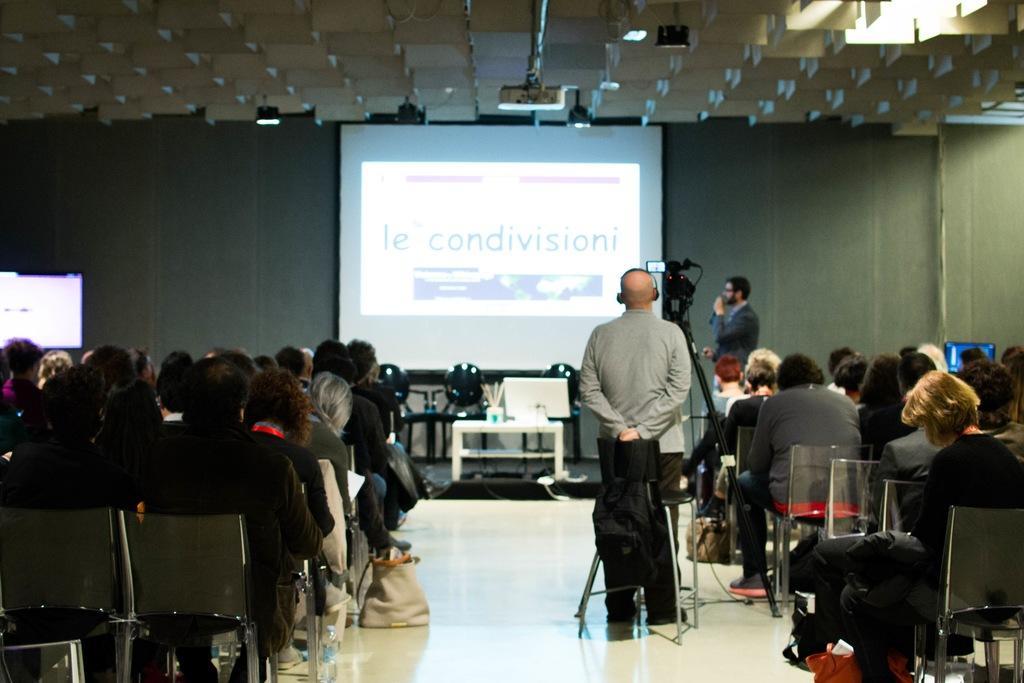How would you summarize this image in a sentence or two? In this image, we can see a group of people. Few people are sitting on the chairs. In the middle and background of the image, we can see two men are standing. Background we can see wall, screen, television, chairs, table and few objects. Top of the image, we can see the projector. Here we can see a camera with stand. 